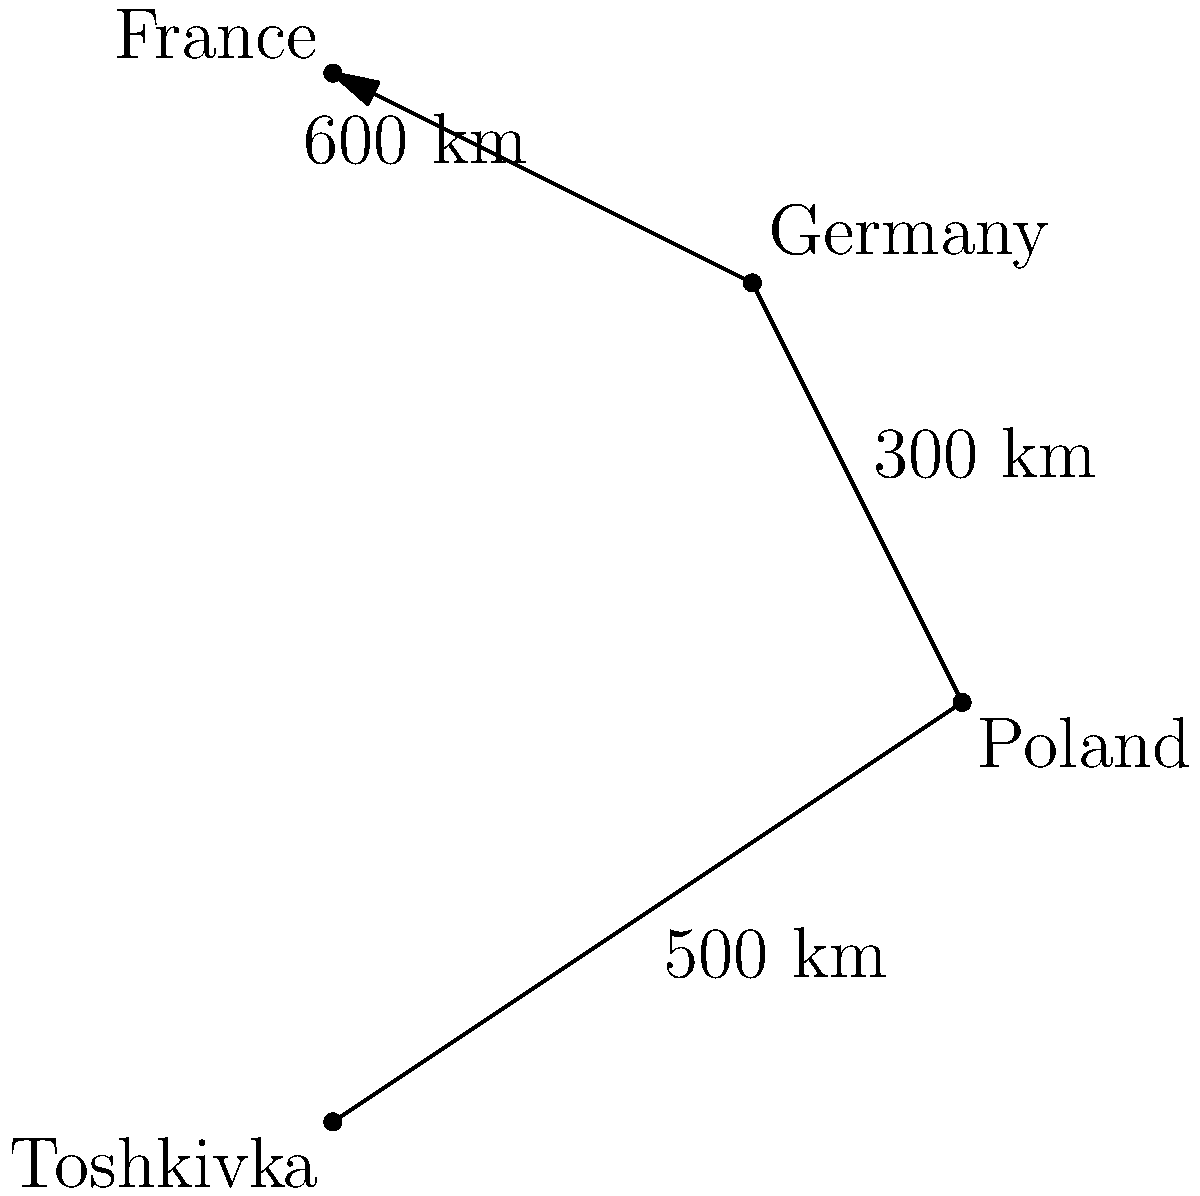Using the simplified map provided, calculate the total distance traveled if you were to flee from Toshkivka to France, passing through Poland and Germany. What is the shortest route in kilometers? To find the shortest route from Toshkivka to France, we need to add up the distances between each stop:

1. Distance from Toshkivka to Poland: 500 km
2. Distance from Poland to Germany: 300 km
3. Distance from Germany to France: 600 km

Total distance: $500 + 300 + 600 = 1400$ km

The map shows only one route, passing through all three countries, so this is the shortest (and only) route given.
Answer: 1400 km 